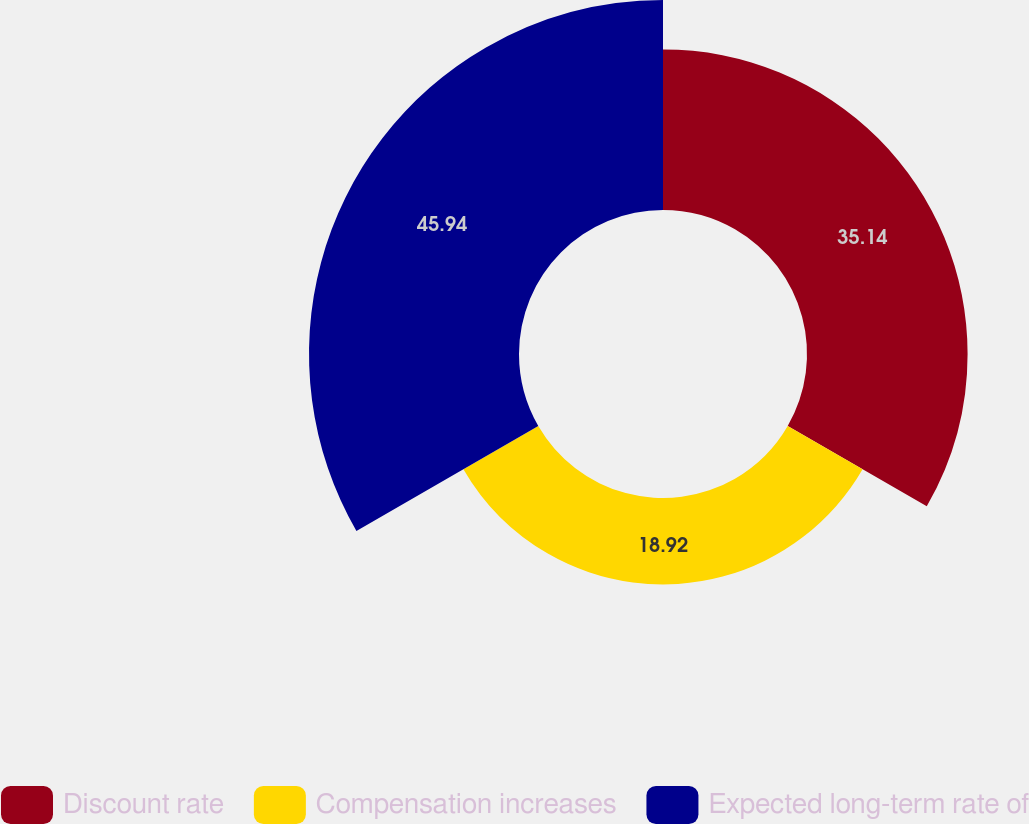Convert chart. <chart><loc_0><loc_0><loc_500><loc_500><pie_chart><fcel>Discount rate<fcel>Compensation increases<fcel>Expected long-term rate of<nl><fcel>35.14%<fcel>18.92%<fcel>45.95%<nl></chart> 